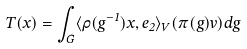<formula> <loc_0><loc_0><loc_500><loc_500>T ( x ) = \int _ { G } \langle \rho ( g ^ { - 1 } ) x , e _ { 2 } \rangle _ { V } ( \pi ( g ) v ) d g</formula> 